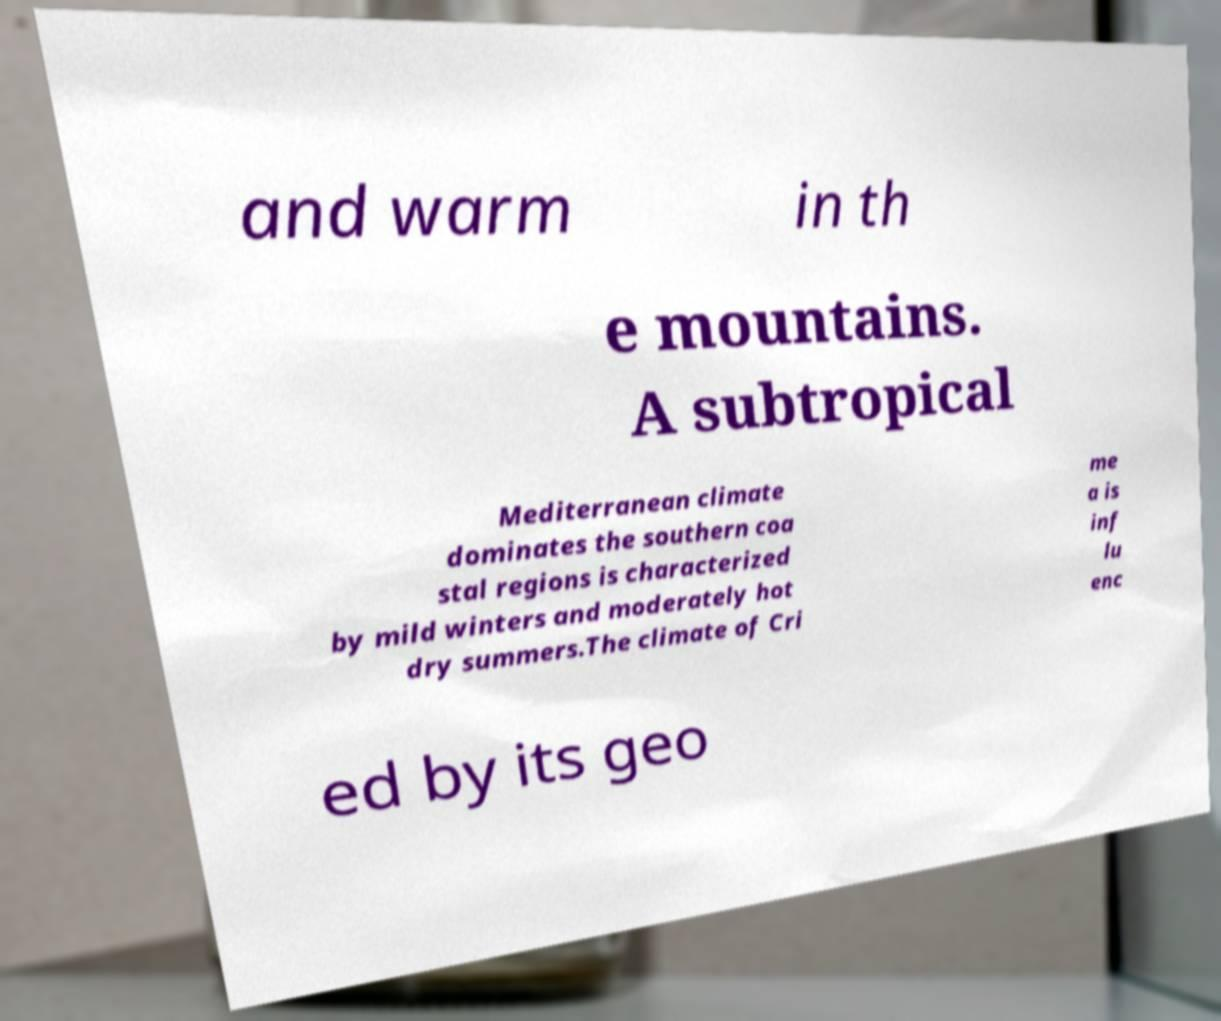What messages or text are displayed in this image? I need them in a readable, typed format. and warm in th e mountains. A subtropical Mediterranean climate dominates the southern coa stal regions is characterized by mild winters and moderately hot dry summers.The climate of Cri me a is inf lu enc ed by its geo 